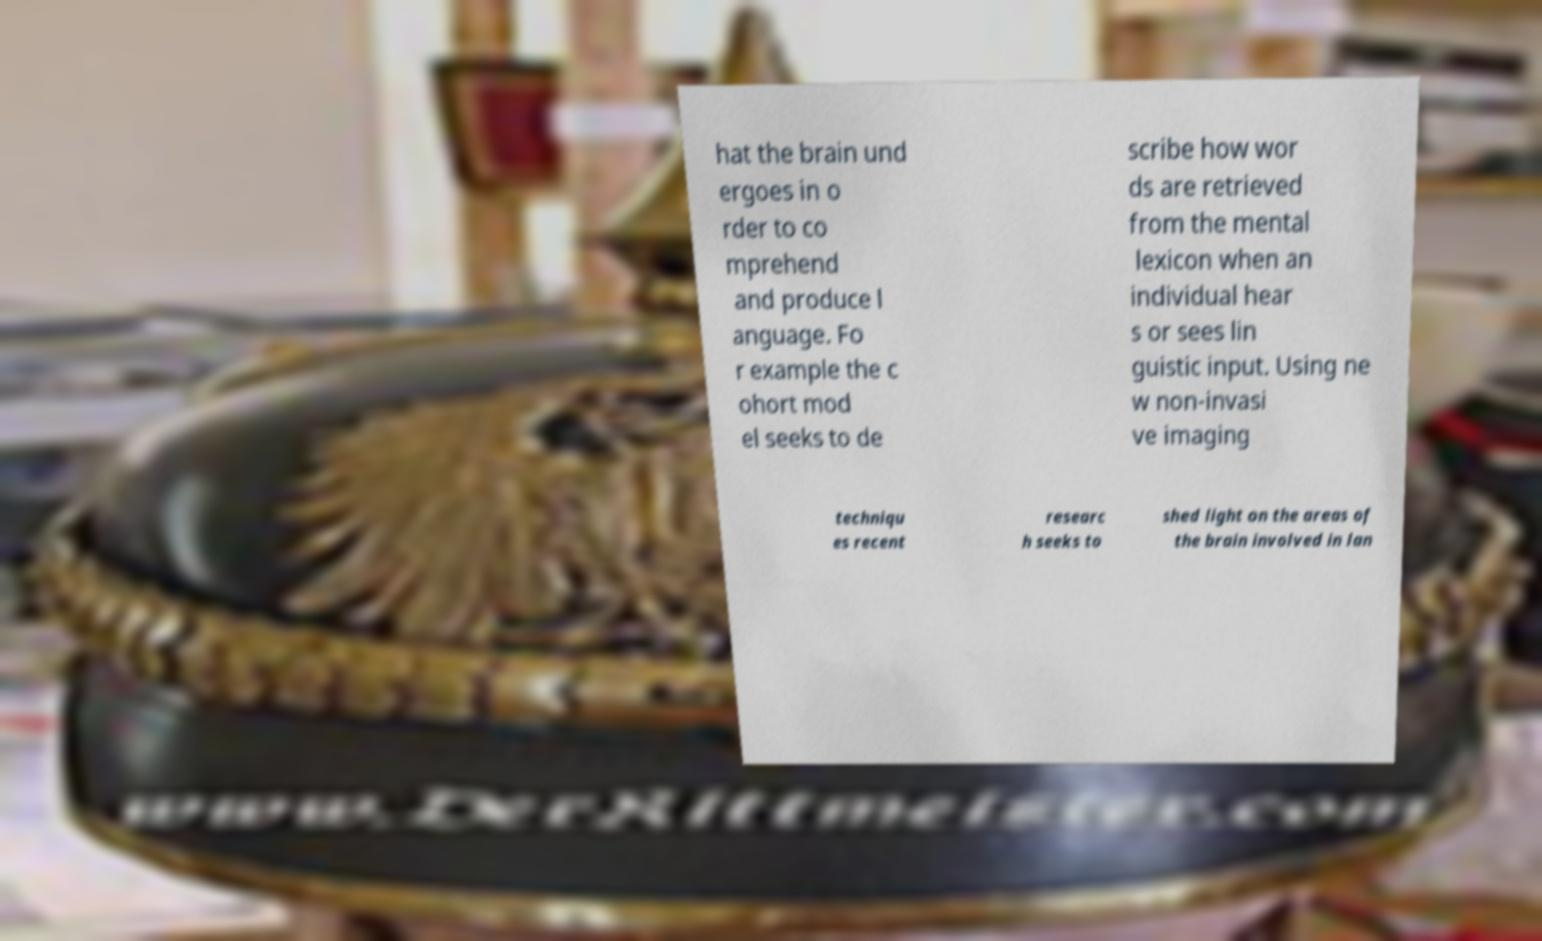Can you read and provide the text displayed in the image?This photo seems to have some interesting text. Can you extract and type it out for me? hat the brain und ergoes in o rder to co mprehend and produce l anguage. Fo r example the c ohort mod el seeks to de scribe how wor ds are retrieved from the mental lexicon when an individual hear s or sees lin guistic input. Using ne w non-invasi ve imaging techniqu es recent researc h seeks to shed light on the areas of the brain involved in lan 